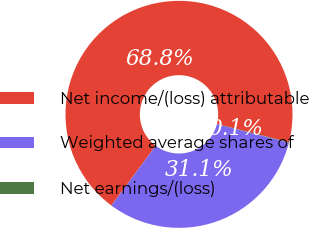Convert chart to OTSL. <chart><loc_0><loc_0><loc_500><loc_500><pie_chart><fcel>Net income/(loss) attributable<fcel>Weighted average shares of<fcel>Net earnings/(loss)<nl><fcel>68.81%<fcel>31.13%<fcel>0.06%<nl></chart> 